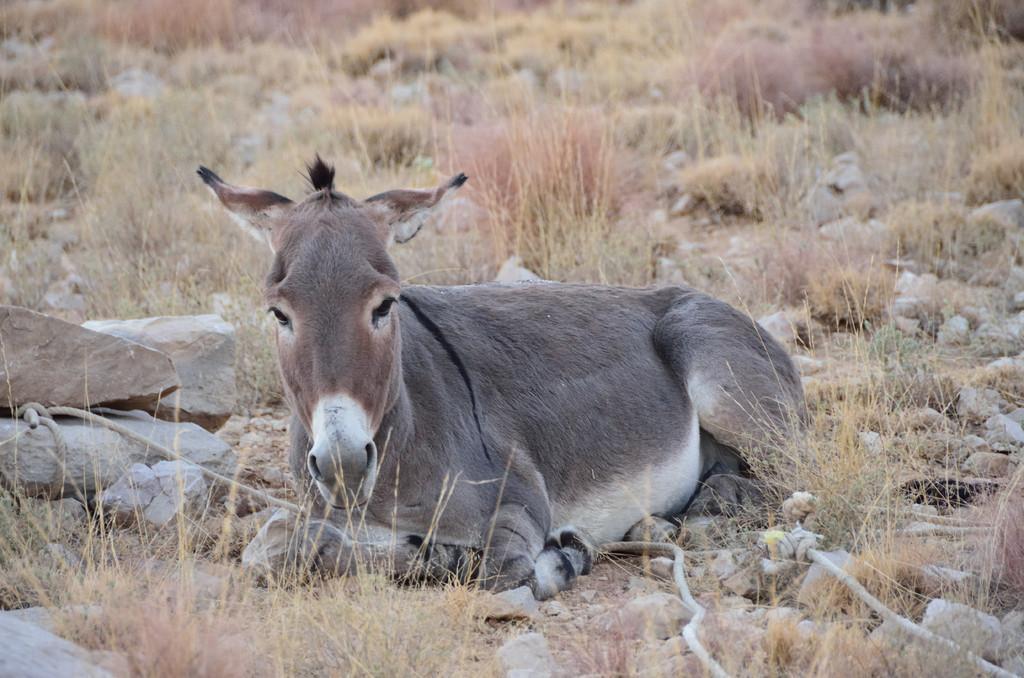In one or two sentences, can you explain what this image depicts? This image consists of a donkey sitting on the ground. At the bottom, we can see rocks and dry grass. 